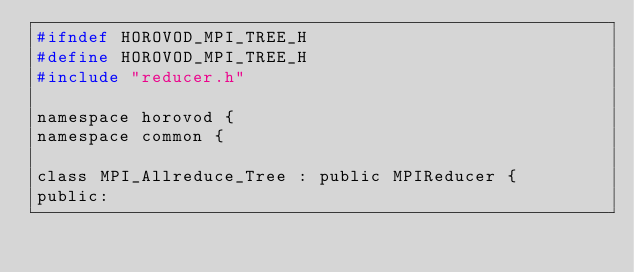Convert code to text. <code><loc_0><loc_0><loc_500><loc_500><_C_>#ifndef HOROVOD_MPI_TREE_H
#define HOROVOD_MPI_TREE_H
#include "reducer.h"

namespace horovod {
namespace common {

class MPI_Allreduce_Tree : public MPIReducer {
public:</code> 